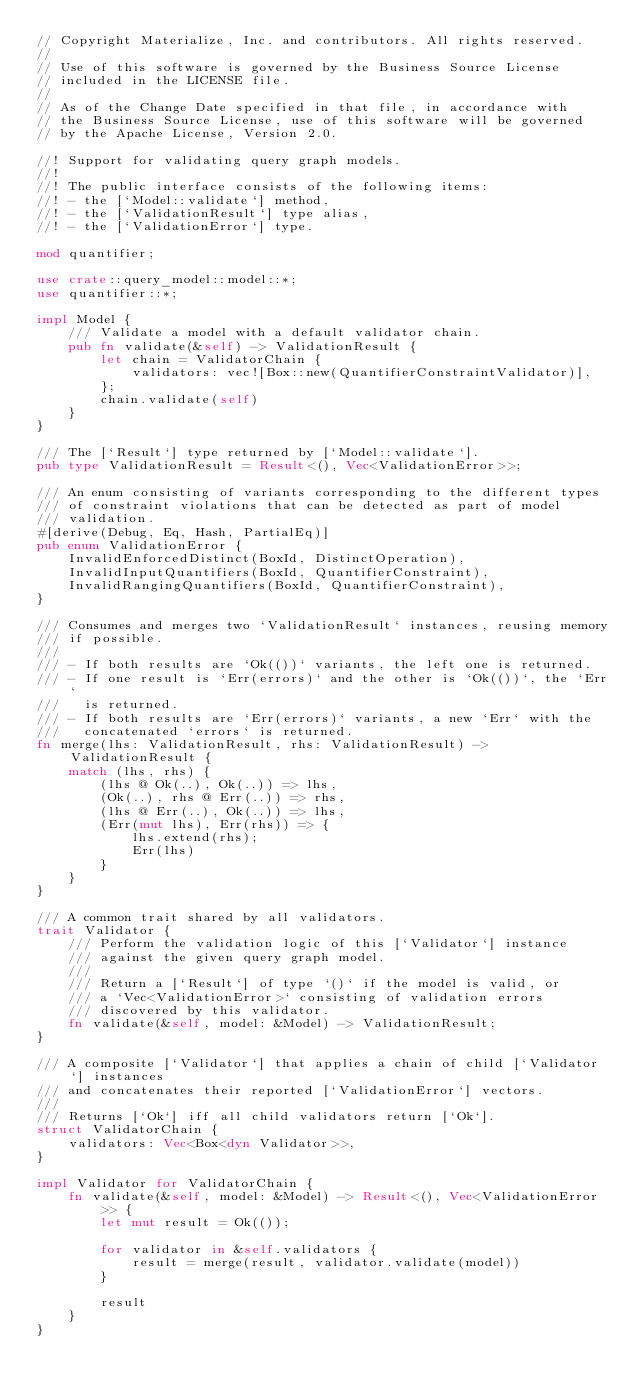<code> <loc_0><loc_0><loc_500><loc_500><_Rust_>// Copyright Materialize, Inc. and contributors. All rights reserved.
//
// Use of this software is governed by the Business Source License
// included in the LICENSE file.
//
// As of the Change Date specified in that file, in accordance with
// the Business Source License, use of this software will be governed
// by the Apache License, Version 2.0.

//! Support for validating query graph models.
//!
//! The public interface consists of the following items:
//! - the [`Model::validate`] method,
//! - the [`ValidationResult`] type alias,
//! - the [`ValidationError`] type.

mod quantifier;

use crate::query_model::model::*;
use quantifier::*;

impl Model {
    /// Validate a model with a default validator chain.
    pub fn validate(&self) -> ValidationResult {
        let chain = ValidatorChain {
            validators: vec![Box::new(QuantifierConstraintValidator)],
        };
        chain.validate(self)
    }
}

/// The [`Result`] type returned by [`Model::validate`].
pub type ValidationResult = Result<(), Vec<ValidationError>>;

/// An enum consisting of variants corresponding to the different types
/// of constraint violations that can be detected as part of model
/// validation.
#[derive(Debug, Eq, Hash, PartialEq)]
pub enum ValidationError {
    InvalidEnforcedDistinct(BoxId, DistinctOperation),
    InvalidInputQuantifiers(BoxId, QuantifierConstraint),
    InvalidRangingQuantifiers(BoxId, QuantifierConstraint),
}

/// Consumes and merges two `ValidationResult` instances, reusing memory
/// if possible.
///
/// - If both results are `Ok(())` variants, the left one is returned.
/// - If one result is `Err(errors)` and the other is `Ok(())`, the `Err`
///   is returned.
/// - If both results are `Err(errors)` variants, a new `Err` with the
///   concatenated `errors` is returned.
fn merge(lhs: ValidationResult, rhs: ValidationResult) -> ValidationResult {
    match (lhs, rhs) {
        (lhs @ Ok(..), Ok(..)) => lhs,
        (Ok(..), rhs @ Err(..)) => rhs,
        (lhs @ Err(..), Ok(..)) => lhs,
        (Err(mut lhs), Err(rhs)) => {
            lhs.extend(rhs);
            Err(lhs)
        }
    }
}

/// A common trait shared by all validators.
trait Validator {
    /// Perform the validation logic of this [`Validator`] instance
    /// against the given query graph model.
    ///
    /// Return a [`Result`] of type `()` if the model is valid, or
    /// a `Vec<ValidationError>` consisting of validation errors
    /// discovered by this validator.
    fn validate(&self, model: &Model) -> ValidationResult;
}

/// A composite [`Validator`] that applies a chain of child [`Validator`] instances
/// and concatenates their reported [`ValidationError`] vectors.
///
/// Returns [`Ok`] iff all child validators return [`Ok`].
struct ValidatorChain {
    validators: Vec<Box<dyn Validator>>,
}

impl Validator for ValidatorChain {
    fn validate(&self, model: &Model) -> Result<(), Vec<ValidationError>> {
        let mut result = Ok(());

        for validator in &self.validators {
            result = merge(result, validator.validate(model))
        }

        result
    }
}
</code> 